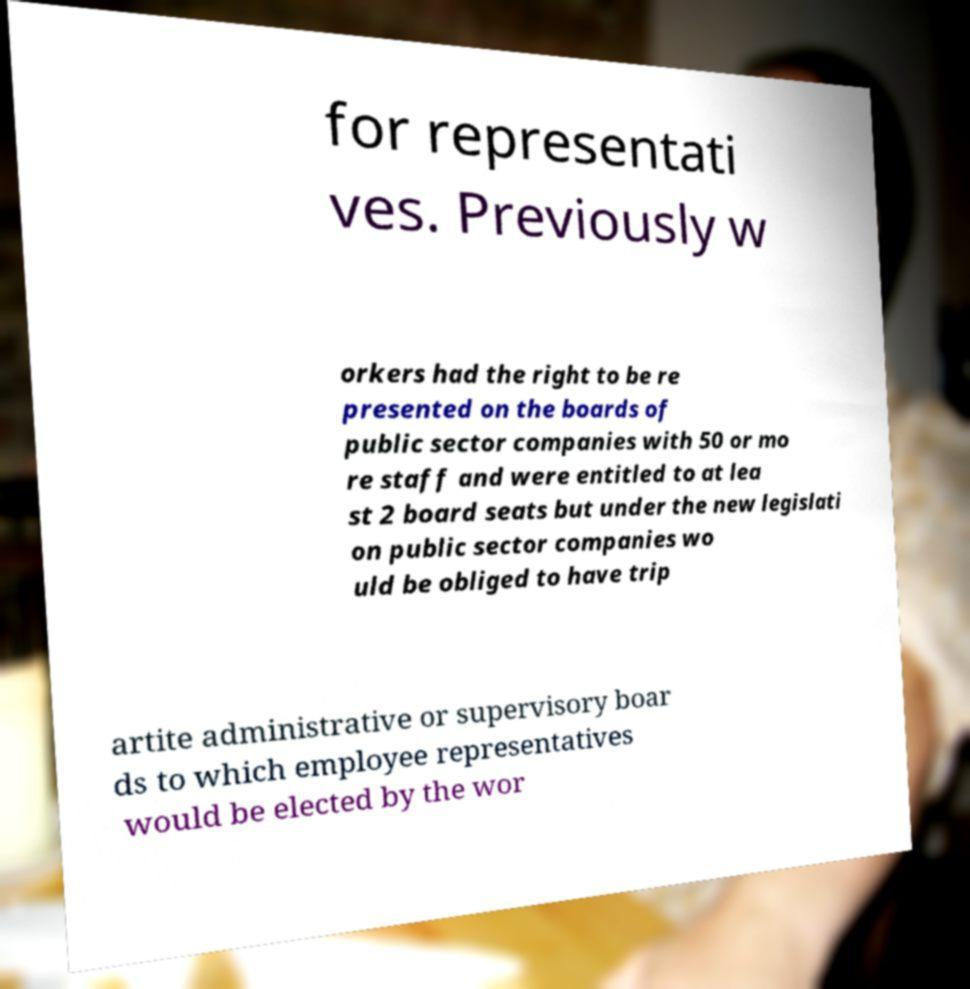Can you read and provide the text displayed in the image?This photo seems to have some interesting text. Can you extract and type it out for me? for representati ves. Previously w orkers had the right to be re presented on the boards of public sector companies with 50 or mo re staff and were entitled to at lea st 2 board seats but under the new legislati on public sector companies wo uld be obliged to have trip artite administrative or supervisory boar ds to which employee representatives would be elected by the wor 